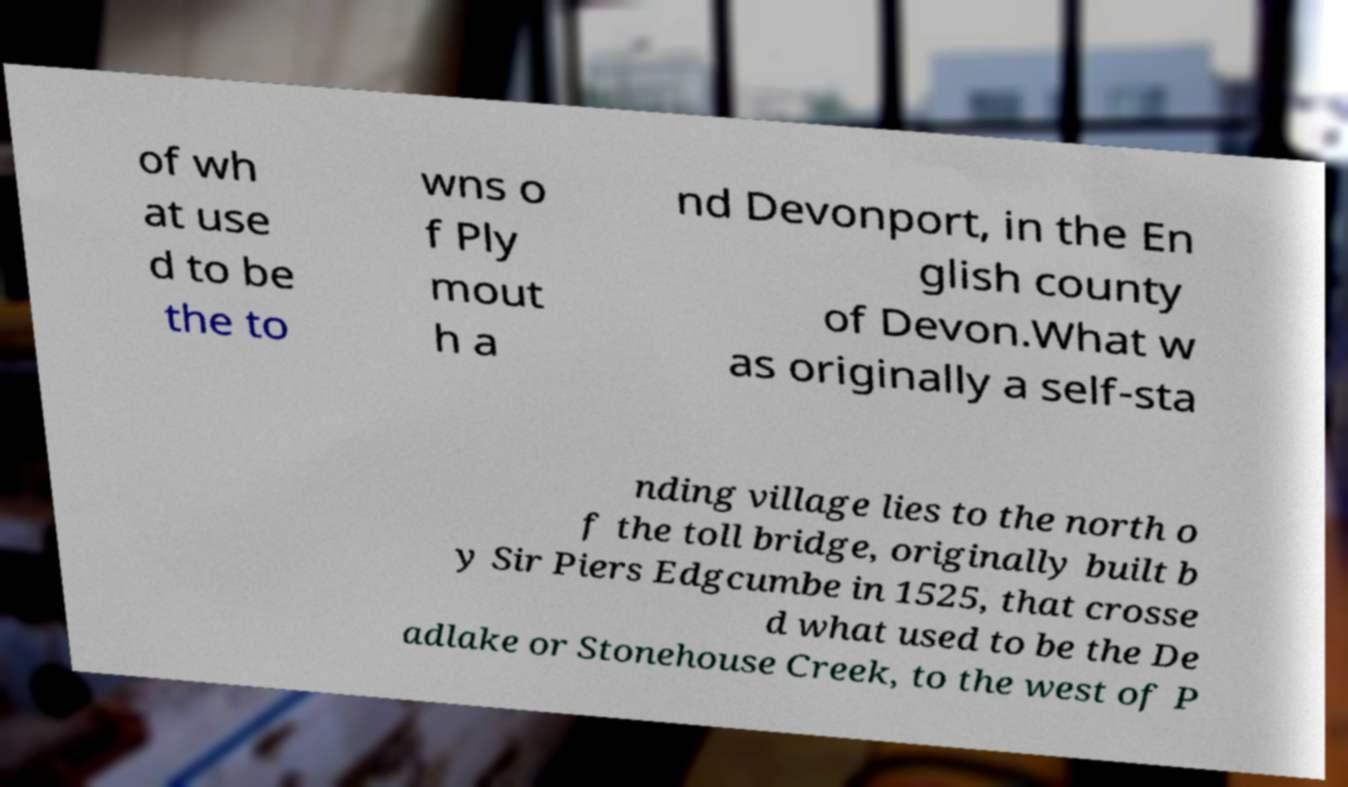I need the written content from this picture converted into text. Can you do that? of wh at use d to be the to wns o f Ply mout h a nd Devonport, in the En glish county of Devon.What w as originally a self-sta nding village lies to the north o f the toll bridge, originally built b y Sir Piers Edgcumbe in 1525, that crosse d what used to be the De adlake or Stonehouse Creek, to the west of P 